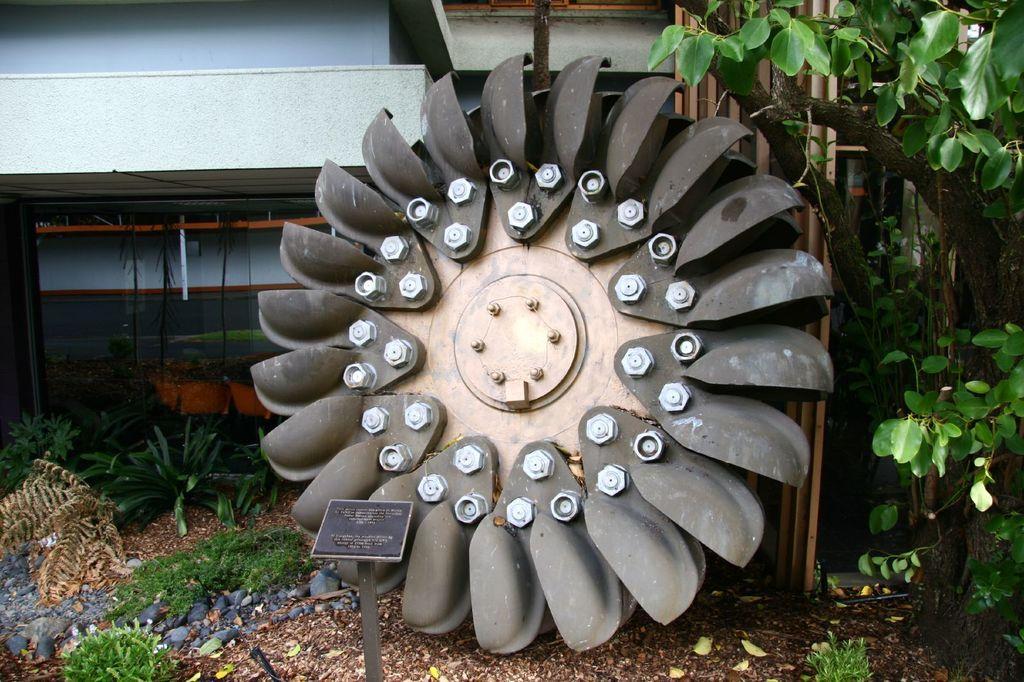Describe this image in one or two sentences. There is turbine arranged on the ground near a hoarding which is attached to the stand. On the left side, there are plants and grass on the ground. On the right side, there is a tree and a plant. In the background, there is a building. 